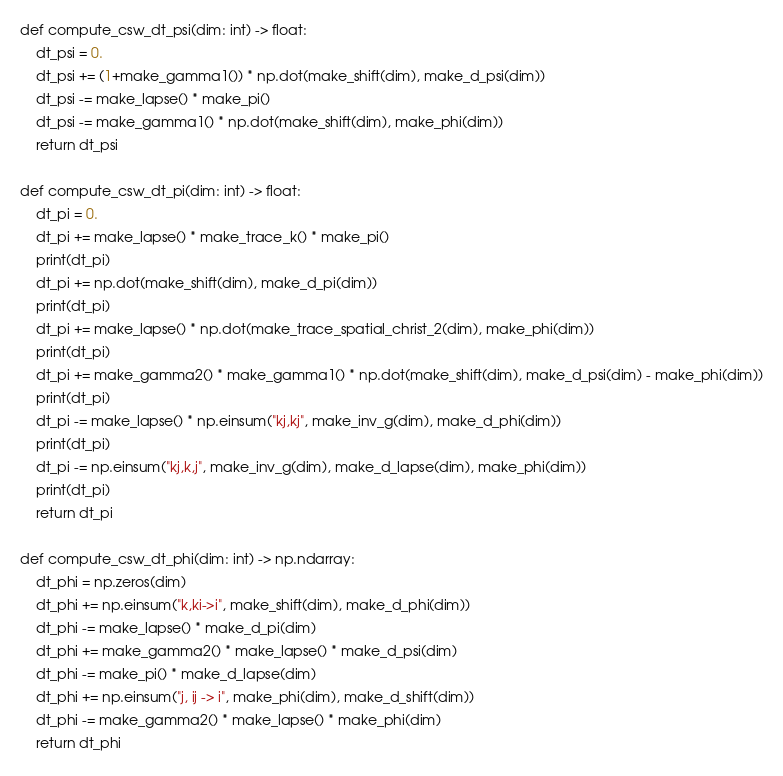<code> <loc_0><loc_0><loc_500><loc_500><_Python_>def compute_csw_dt_psi(dim: int) -> float:
    dt_psi = 0.
    dt_psi += (1+make_gamma1()) * np.dot(make_shift(dim), make_d_psi(dim))
    dt_psi -= make_lapse() * make_pi()
    dt_psi -= make_gamma1() * np.dot(make_shift(dim), make_phi(dim))
    return dt_psi

def compute_csw_dt_pi(dim: int) -> float:
    dt_pi = 0.
    dt_pi += make_lapse() * make_trace_k() * make_pi()
    print(dt_pi)
    dt_pi += np.dot(make_shift(dim), make_d_pi(dim))
    print(dt_pi)
    dt_pi += make_lapse() * np.dot(make_trace_spatial_christ_2(dim), make_phi(dim))
    print(dt_pi)
    dt_pi += make_gamma2() * make_gamma1() * np.dot(make_shift(dim), make_d_psi(dim) - make_phi(dim))
    print(dt_pi)
    dt_pi -= make_lapse() * np.einsum("kj,kj", make_inv_g(dim), make_d_phi(dim))
    print(dt_pi)
    dt_pi -= np.einsum("kj,k,j", make_inv_g(dim), make_d_lapse(dim), make_phi(dim))
    print(dt_pi)
    return dt_pi

def compute_csw_dt_phi(dim: int) -> np.ndarray:
    dt_phi = np.zeros(dim)
    dt_phi += np.einsum("k,ki->i", make_shift(dim), make_d_phi(dim))
    dt_phi -= make_lapse() * make_d_pi(dim)
    dt_phi += make_gamma2() * make_lapse() * make_d_psi(dim)
    dt_phi -= make_pi() * make_d_lapse(dim)
    dt_phi += np.einsum("j, ij -> i", make_phi(dim), make_d_shift(dim))
    dt_phi -= make_gamma2() * make_lapse() * make_phi(dim)
    return dt_phi


</code> 